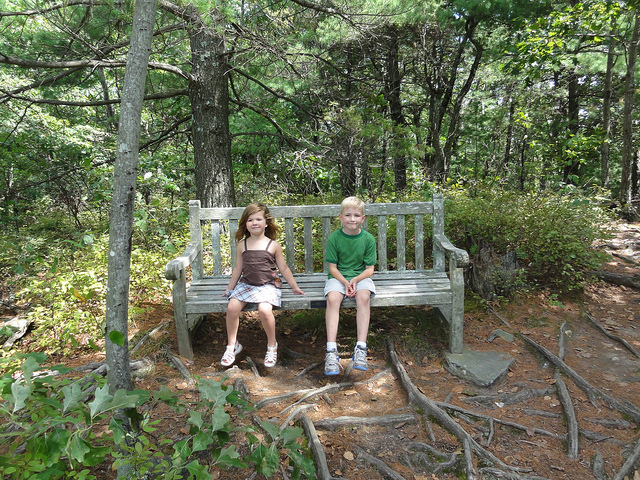Imagine a fantasy story starting on this bench. Two children sat on an old wooden bench in the heart of the forest. Unbeknownst to them, this bench was the gateway to a magical realm. As they sat there, a shimmering portal began to form before them, glowing with an ethereal light. They exchanged excited glances and cautiously stepped through the portal, finding themselves in a land of towering castles, mystic creatures, and enchanted forests. This bench had transported them to a world beyond their wildest imaginations, where their adventure was just beginning. What happens next in the story? The children found themselves in a vibrant, fantastical forest unlike anything they had ever seen. The trees were tall and twisted, their leaves glowing with soft bioluminescence. As they wandered deeper into the forest, they encountered a talking fox who introduced himself as Zephyr, the guardian of the forest. Zephyr told them that an ancient prophecy foretold their arrival and that they were destined to find the lost Crystal of Harmony, which had the power to bring peace to the troubled land. With Zephyr as their guide, the children set out on a thrilling quest, facing magical creatures, solving ancient riddles, and uncovering the hidden secrets of the enchanted forest. How do they face their first challenge? Their first challenge came in the form of a tangled thicket, enchanted to prevent any intruders from passing through. With Zephyr's advice, they discovered that only a melody played by a special flute could untangle the thicket. The children found an old, ornately carved flute hidden in the undergrowth nearby. One of them started playing it, and sure enough, the magical melody caused the thicket to unwind, creating a path for them to continue their journey. This test of resourcefulness and courage boosted their confidence as they ventured deeper into the enchanted land. 